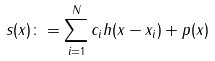Convert formula to latex. <formula><loc_0><loc_0><loc_500><loc_500>s ( x ) \colon = \sum _ { i = 1 } ^ { N } c _ { i } h ( x - x _ { i } ) + p ( x )</formula> 